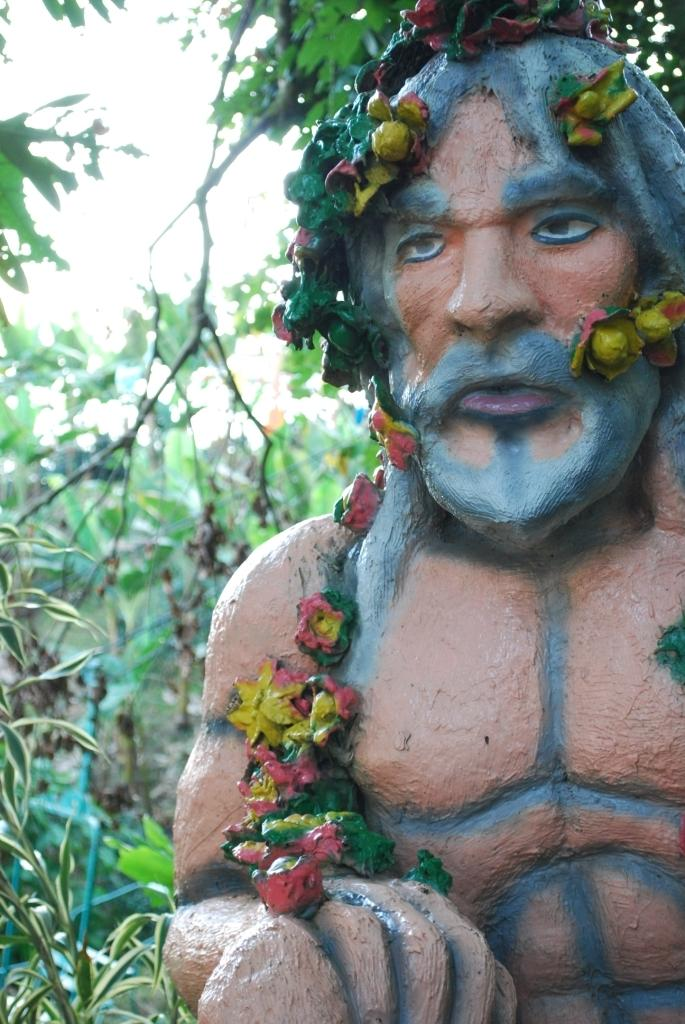What is the main subject in the image? There is a sculpture in the image. What can be seen on the left side of the image? There are trees and the sky visible on the left side of the image. How many rods are being used by the woman in the image? There is no woman present in the image, and therefore no rods being used. 